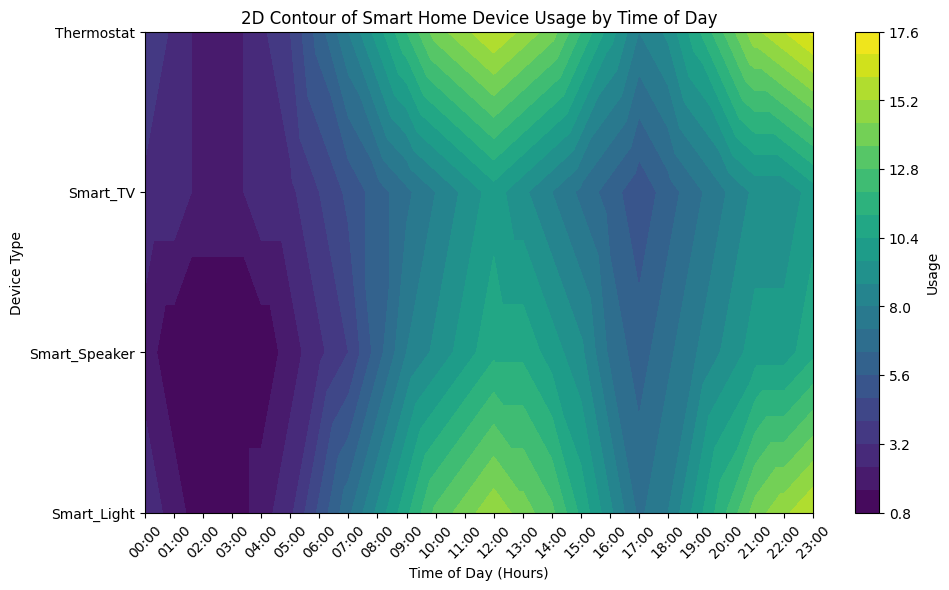What's the peak usage time for the Smart Light? By observing the figure, the Smart Light’s usage peaks at the highest contour level, around 23:00. The y-axis label will help identify the correct contour corresponding to Smart Light, confirming the peak time of 23:00
Answer: 23:00 Which device type has the earliest peak usage? Compare the contours' highest points along the x-axis for each device type. The y-axis indicates different device types. The contours for the Thermostat peak earliest around 23:00
Answer: Thermostat Which device has the highest variation in usage over the day? Observe the range of contours for each device. The Smart Light shows the greatest variation from low to high contours, indicating high usage variation throughout the day
Answer: Smart Light Between 12:00 and 18:00, which device type shows the most consistent usage? Look at the contour patterns in the specified time range (12:00 to 18:00) for uniformity. The Smart Speaker shows less variation in contour levels, indicating consistent usage
Answer: Smart Speaker 